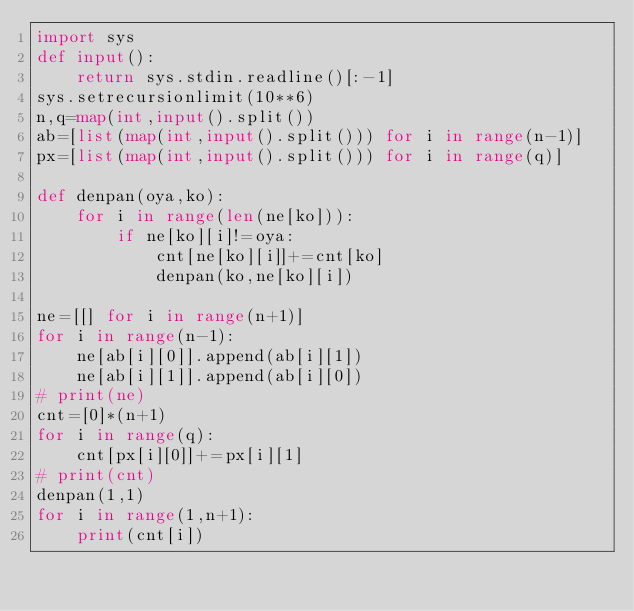<code> <loc_0><loc_0><loc_500><loc_500><_Python_>import sys
def input():
    return sys.stdin.readline()[:-1]
sys.setrecursionlimit(10**6)
n,q=map(int,input().split())
ab=[list(map(int,input().split())) for i in range(n-1)]
px=[list(map(int,input().split())) for i in range(q)]

def denpan(oya,ko):
    for i in range(len(ne[ko])):
        if ne[ko][i]!=oya:
            cnt[ne[ko][i]]+=cnt[ko]
            denpan(ko,ne[ko][i])

ne=[[] for i in range(n+1)]
for i in range(n-1):
    ne[ab[i][0]].append(ab[i][1])
    ne[ab[i][1]].append(ab[i][0])
# print(ne)
cnt=[0]*(n+1)
for i in range(q):
    cnt[px[i][0]]+=px[i][1]
# print(cnt)
denpan(1,1)
for i in range(1,n+1):
    print(cnt[i])</code> 